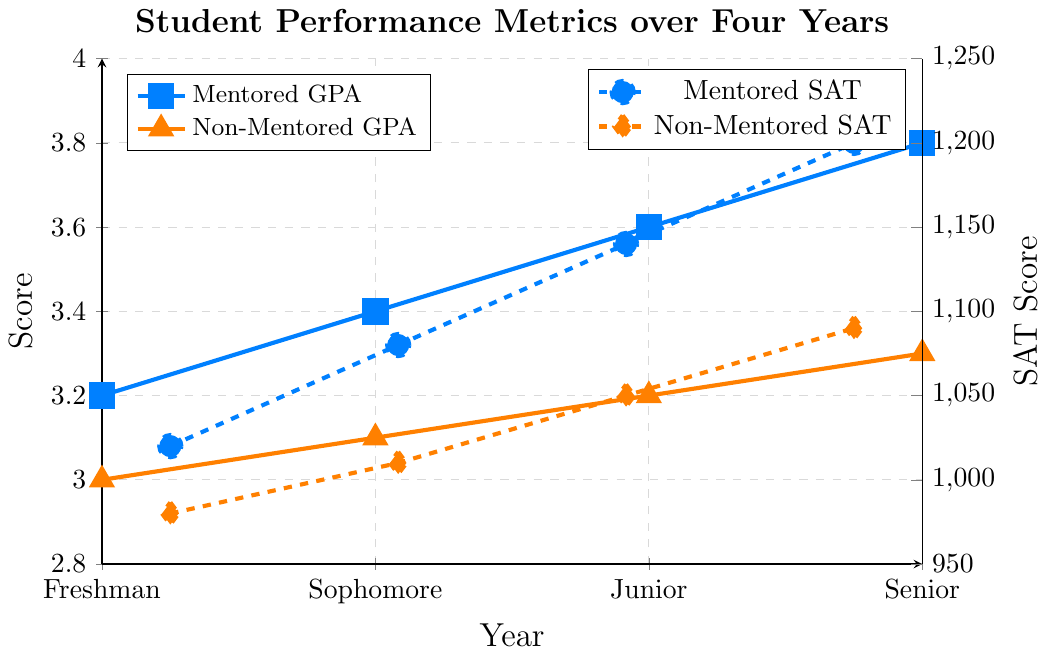What is the difference in GPA between mentored and non-mentored students in their Junior year? The GPA for mentored students in their Junior year is 3.6, while for non-mentored students it is 3.2. The difference is calculated as 3.6 - 3.2.
Answer: 0.4 Which group had a higher SAT score in the Senior year and by how much? Mentored students had an SAT score of 1200, and non-mentored students had a score of 1090 in the Senior year. The difference is 1200 - 1090.
Answer: Mentored by 110 How much did the SAT score for mentored students increase from Freshman to Senior year? The SAT score for mentored students in Freshman year is 1020 and in Senior year is 1200. The increase is 1200 - 1020.
Answer: 180 What is the average GPA of mentored students over the four years? The GPA values for mentored students over the four years are 3.2, 3.4, 3.6, and 3.8. The average is calculated as (3.2 + 3.4 + 3.6 + 3.8) / 4.
Answer: 3.5 Compare the slopes of the lines representing GPA and SAT scores for mentored students. Which line is steeper? The slope of the GPA line for mentored students over four years is (3.8 - 3.2)/(3 - 0) = 0.2. The slope of the SAT line is (1200 - 1020)/(3 - 0) = 60. Since the SAT score change per year (60) is greater than the GPA change per year (0.2), the SAT line is steeper.
Answer: SAT line Which group showed consistently higher GPA scores every year? By comparing the GPA values year by year, mentored students had higher GPA scores than non-mentored students every year.
Answer: Mentored What is the combined total increase in SAT scores for both groups from Freshman to Senior year? Mentored SAT increased by 180, and Non-Mentored SAT increased by 110. The combined increase is 180 + 110.
Answer: 290 How much did the GPA disparity between mentored and non-mentored students change from Freshman to Senior year? The GPA disparity in the Freshman year is 3.2 - 3.0 = 0.2, and in the Senior year, it is 3.8 - 3.3 = 0.5. The change in disparity is 0.5 - 0.2.
Answer: 0.3 Were the SAT scores for non-mentored students ever equal to or higher than those for mentored students at any point? Reviewing the SAT scores for all four years, non-mentored students never had SAT scores equal to or higher than mentored students.
Answer: No 